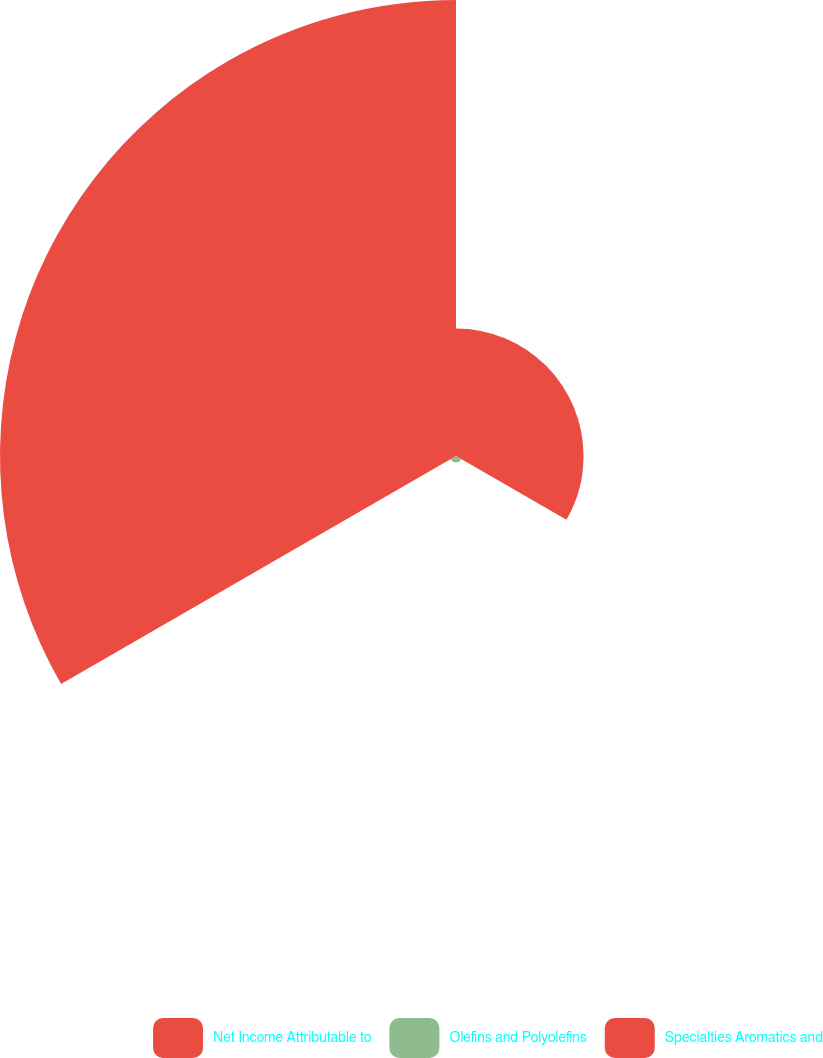Convert chart. <chart><loc_0><loc_0><loc_500><loc_500><pie_chart><fcel>Net Income Attributable to<fcel>Olefins and Polyolefins<fcel>Specialties Aromatics and<nl><fcel>21.62%<fcel>1.08%<fcel>77.3%<nl></chart> 